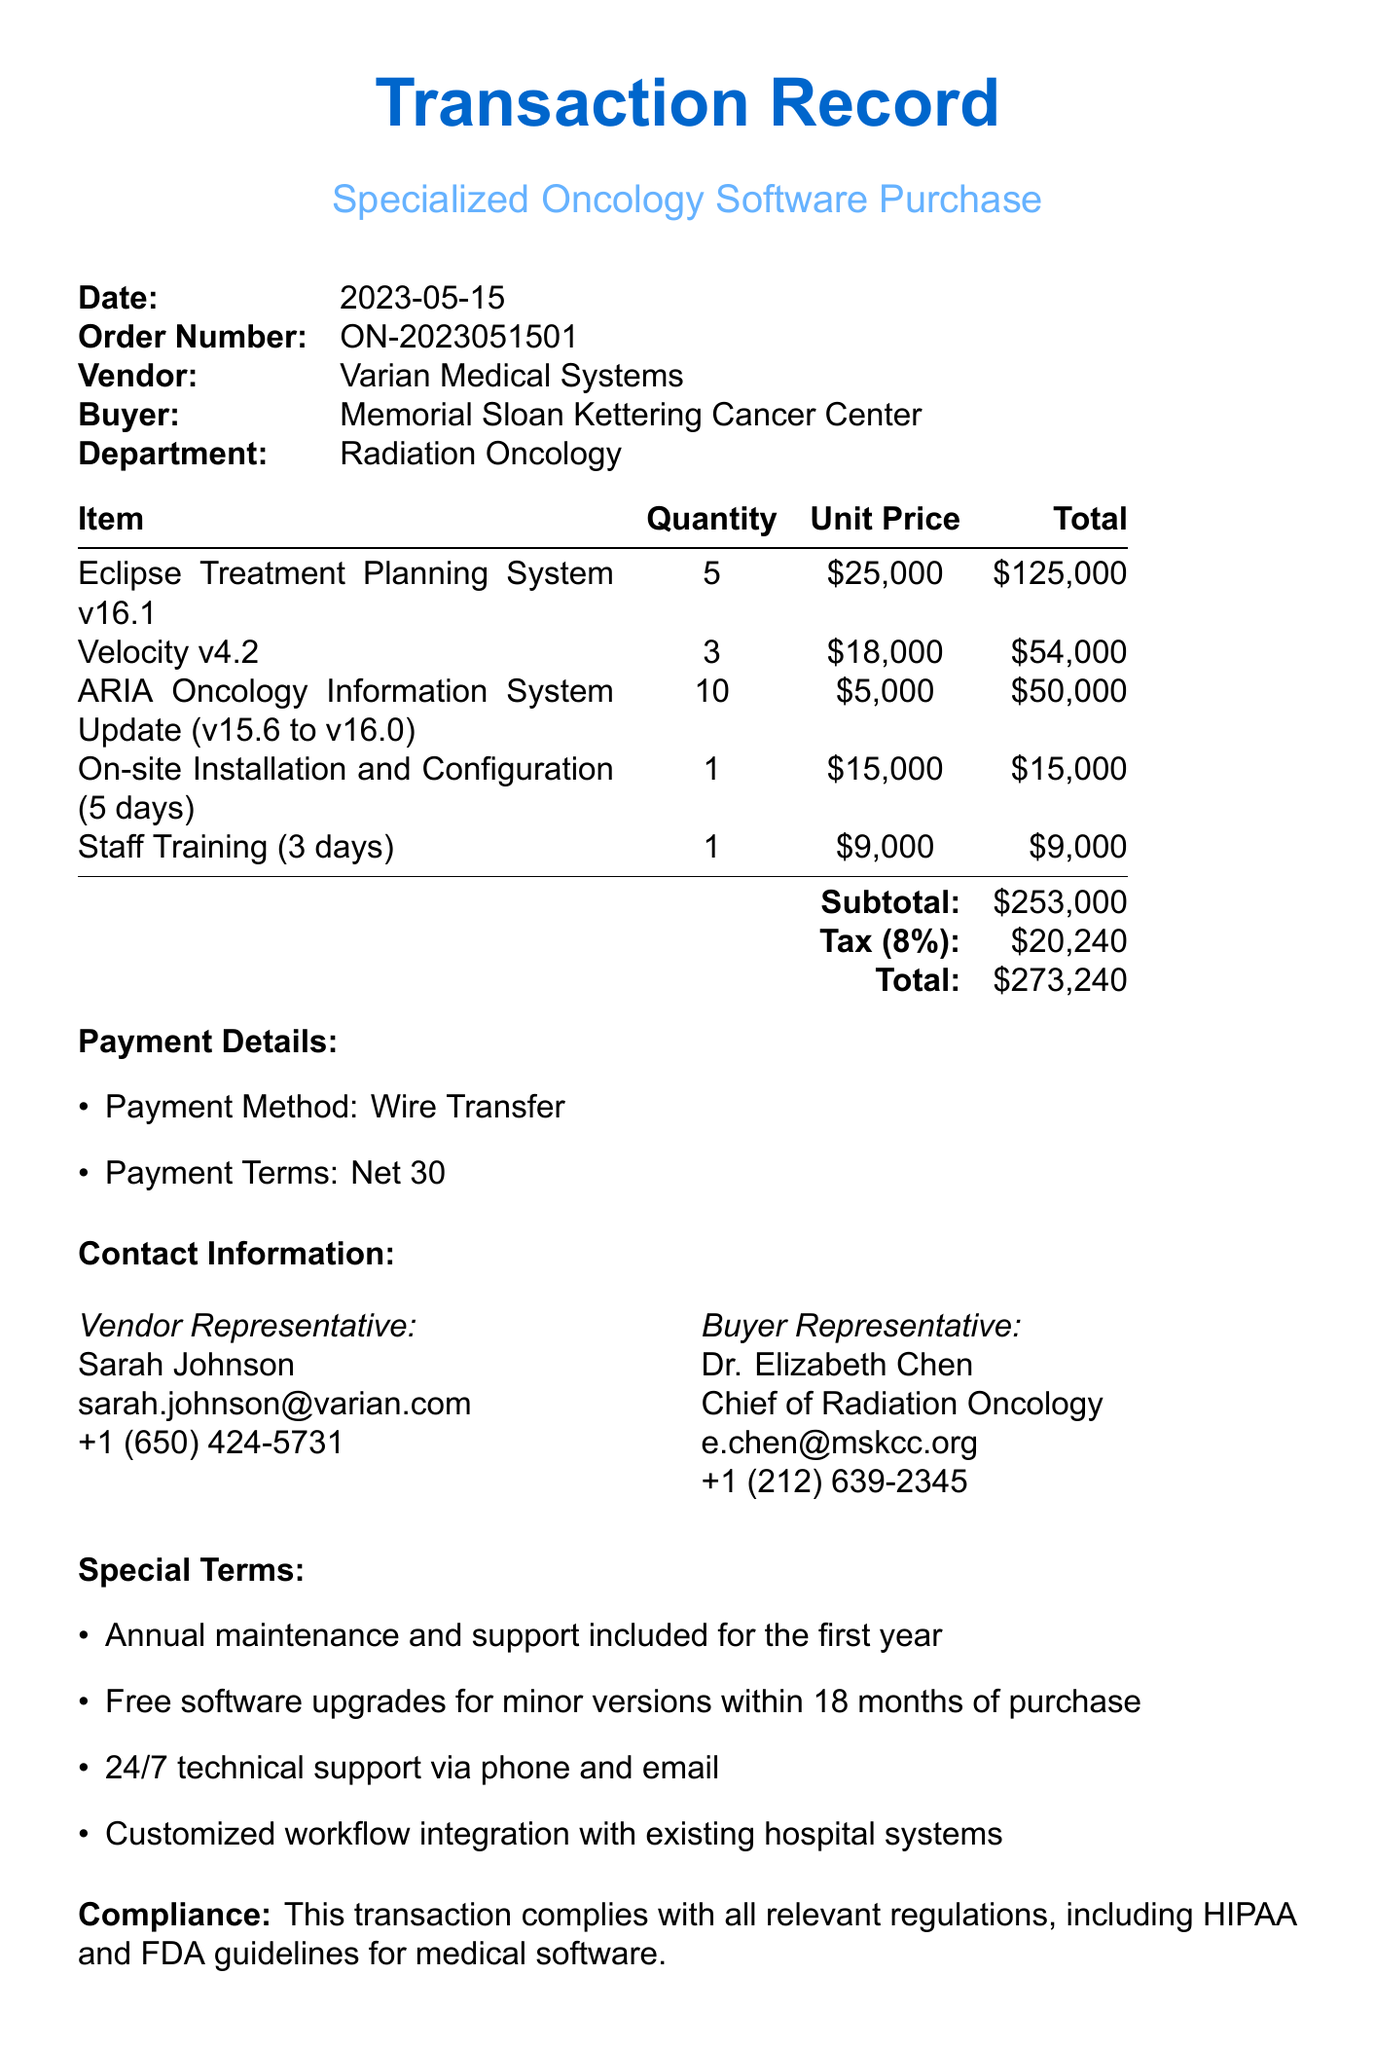What is the date of the transaction? The date of the transaction is provided in the transaction details section of the document.
Answer: 2023-05-15 What is the total amount after tax? The total amount is calculated as the sum of the subtotal and tax amount mentioned at the end of the pricing table.
Answer: 273240 Who is the vendor representative? The name of the vendor representative is listed in the contact information section.
Answer: Sarah Johnson How many licenses of the Eclipse Treatment Planning System were purchased? The quantity of licenses purchased is detailed in the software licenses section.
Answer: 5 What is the price per update for the ARIA Oncology Information System? The price per update is stated in the software updates section of the document.
Answer: 5000 What payment terms are specified in the document? The payment terms are outlined under the payment details section of the document.
Answer: Net 30 What type of warranty is provided by Varian Medical Systems? The warranty details describe the nature and duration of the warranty offered for the software.
Answer: 12 months What additional service has a duration of 5 days? The additional services section lists and describes the services purchased along with their durations.
Answer: On-site Installation and Configuration Are free software upgrades included for minor versions? The special terms section mentions conditions related to software upgrades and support after purchase.
Answer: Yes 